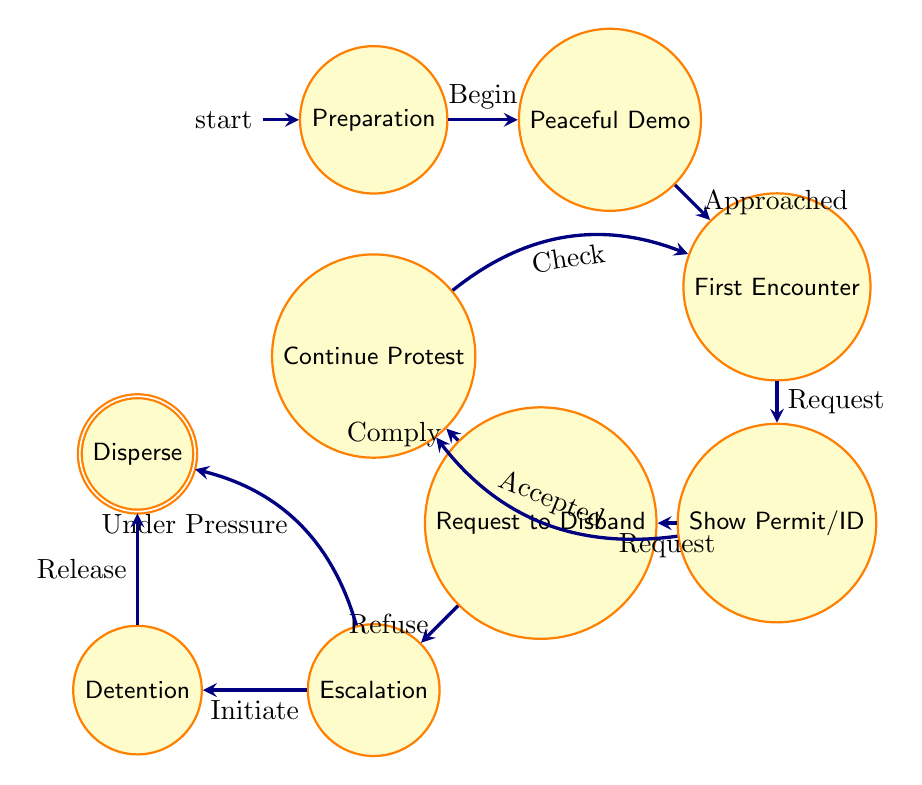What is the starting state of the process? The starting state is identified as "Preparation," which is marked as the initial state in the diagram.
Answer: Preparation How many states are there in total? By counting the nodes in the diagram, there are a total of nine unique states listed.
Answer: Nine What does the state "First Encounter" lead to upon "Request for Permit/ID"? Upon the "Request for Permit/ID" from "First Encounter," the flow moves to the state "Show Permit/ID."
Answer: Show Permit/ID If protesters refuse to disband, what state do they encounter next? If the protesters refuse, they escalate to the state "Escalation," according to the transition labeled "Refuse" from the state "Request to Disband."
Answer: Escalation What happens when the permit or identification is accepted? When the "Permit/ID Accepted" transition occurs, the state moves to "Continue Protest." This transition indicates a positive outcome from providing the requested identification.
Answer: Continue Protest What can lead to "Detention"? The state "Detention" is reached from the "Escalation" state when "Detention Initiated" is triggered by law enforcement action aimed at the protesters.
Answer: Detention How do protesters end the protest under pressure? The protest ends under pressure when the state transitions from "Escalation" to "Disperse" due to the situation forcing the protesters to leave.
Answer: Disperse Which state can lead back to "First Encounter"? The state "Continue Protest" can lead back to "First Encounter" through the transition labeled "Check," indicating subsequent interactions with law enforcement.
Answer: First Encounter In total, how many transitions occur in the diagram? There are ten transitions connecting the states, as seen from the pairs of states and their corresponding actions.
Answer: Ten 